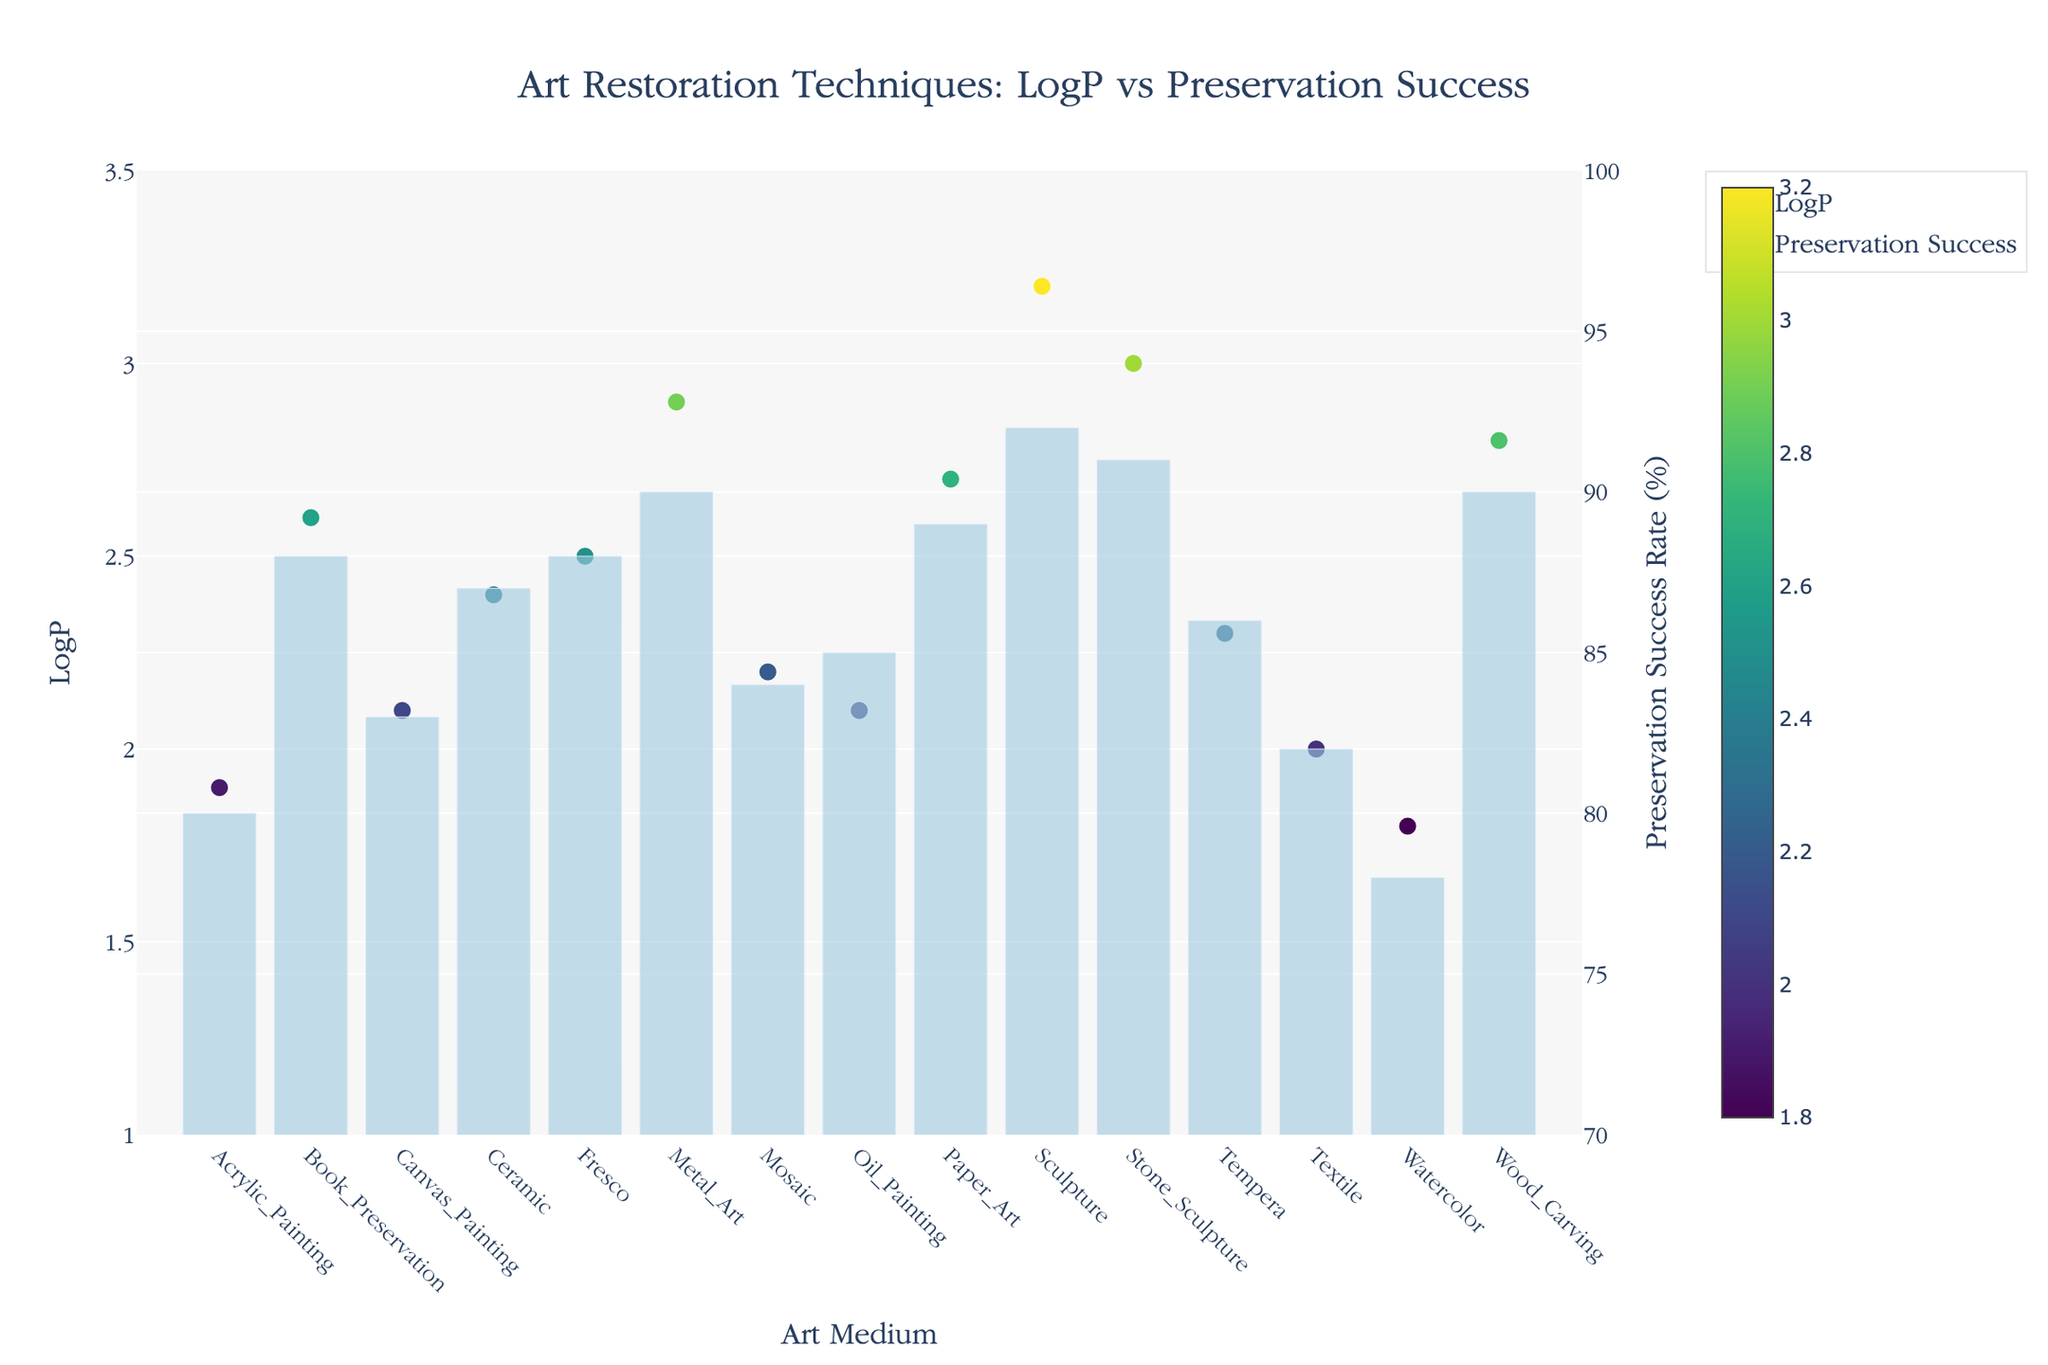What's the title of the figure? The title of the figure is written at the top and summarizes the main topic of the plot. It reads "Art Restoration Techniques: LogP vs Preservation Success".
Answer: Art Restoration Techniques: LogP vs Preservation Success What does the x-axis represent? The x-axis, labeled "Art Medium", represents the different types of art mediums being evaluated in the study.
Answer: Art Medium What is the LogP value for Laser Cleaning on Sculpture? To find this, locate the "Sculpture" on the x-axis and then check the corresponding point's y-value in the scatter plot. The value of LogP for Laser Cleaning is at approximately 3.2.
Answer: 3.2 Which art restoration technique has the highest Preservation Success rate? Look at the bar plot heights and identify which bar is the tallest. The art restoration technique with the highest Preservation Success rate is Laser Cleaning on Sculpture, with a success rate of 92%.
Answer: Laser Cleaning on Sculpture What is the average Preservation Success rate across all art mediums? Sum up all the Preservation Success rates given by the bars and divide by the number of art mediums (15). Calculation: (85+78+92+88+80+86+89+82+90+84+87+88+91+90+83) / 15 ≈ 86.4
Answer: 86.4 Which technique corresponds to the highest LogP value? By looking at the scatter points on the y-axis for LogP, identify the highest point. This corresponds to Laser Cleaning on Sculpture with a LogP value of 3.2.
Answer: Laser Cleaning on Sculpture Compare the Preservation Success of Humidity Control on Textile and Freeze Drying on Book Preservation. Which is higher and by how much? Find the bar heights for Humidity Control on Textile and Freeze Drying on Book Preservation. Humidity Control has a success rate of 82%, and Freeze Drying has 88%. The difference is 88% - 82% = 6%.
Answer: Freeze Drying, by 6% Explain the relationship between LogP and Preservation Success for the art mediums. Analyze the trend between the scatter plot for LogP values and the bar plot for Preservation Success. Generally, higher LogP values tend to correspond to higher Preservation Success rates. For instance, techniques such as Laser Cleaning, with high LogP (3.2), correspond to high success rates (92%), indicating a positive correlation. However, this is not strictly linear, so there are exceptions.
Answer: Positive correlation, with exceptions What is the LogP value range displayed on the y-axis? The y-axis for LogP indicates it ranges from 1 to 3.5.
Answer: 1 to 3.5 How many techniques have a Preservation Success rate above 85%? Count the bars in the bar plot that exceed the 85% mark. Techniques with Success rates above 85% are: Chemical Cleaning, Laser Cleaning, Consolidation, Deacidification, Anoxic Treatment, Solvent Cleaning, Freeze Drying, Resin Infusion, Ultrasonic Cleaning. There are 9 techniques in total.
Answer: 9 